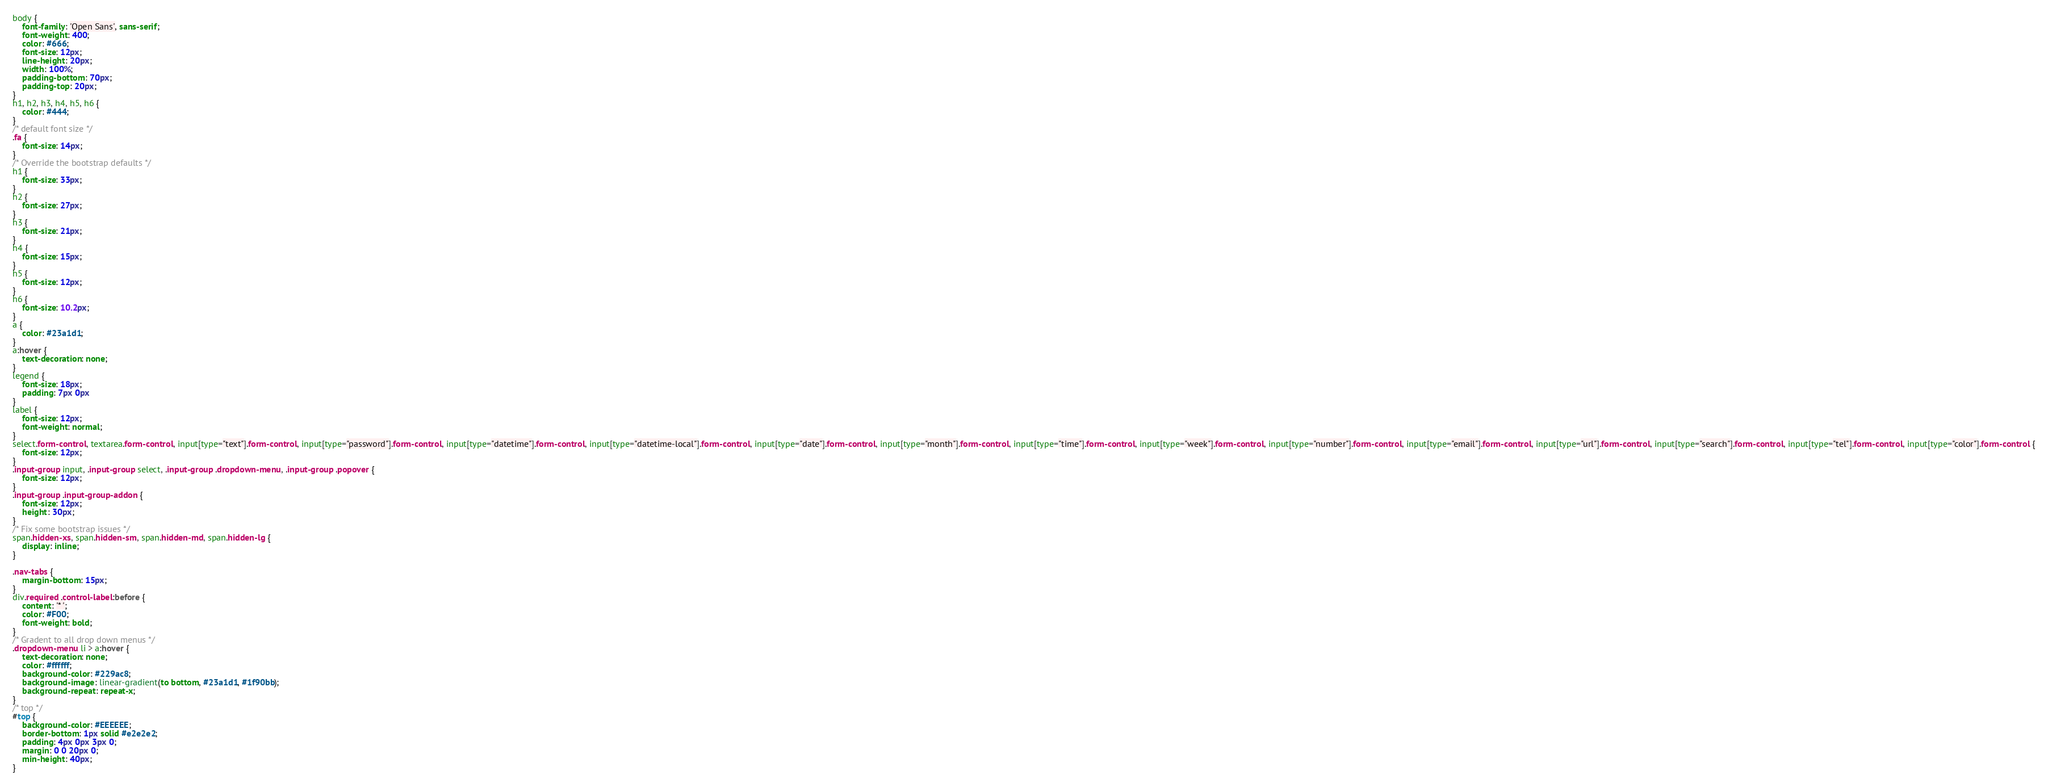<code> <loc_0><loc_0><loc_500><loc_500><_CSS_>body {
	font-family: 'Open Sans', sans-serif;
	font-weight: 400;
	color: #666;
	font-size: 12px;
	line-height: 20px;
	width: 100%;
	padding-bottom: 70px;
	padding-top: 20px;
}
h1, h2, h3, h4, h5, h6 {
	color: #444;
}
/* default font size */
.fa {
	font-size: 14px;
}
/* Override the bootstrap defaults */
h1 {
	font-size: 33px;
}
h2 {
	font-size: 27px;
}
h3 {
	font-size: 21px;
}
h4 {
	font-size: 15px;
}
h5 {
	font-size: 12px;
}
h6 {
	font-size: 10.2px;
}
a {
	color: #23a1d1;
}
a:hover {
	text-decoration: none;
}
legend {
	font-size: 18px;
	padding: 7px 0px
}
label {
	font-size: 12px;
	font-weight: normal;
}
select.form-control, textarea.form-control, input[type="text"].form-control, input[type="password"].form-control, input[type="datetime"].form-control, input[type="datetime-local"].form-control, input[type="date"].form-control, input[type="month"].form-control, input[type="time"].form-control, input[type="week"].form-control, input[type="number"].form-control, input[type="email"].form-control, input[type="url"].form-control, input[type="search"].form-control, input[type="tel"].form-control, input[type="color"].form-control {
	font-size: 12px;
}
.input-group input, .input-group select, .input-group .dropdown-menu, .input-group .popover {
	font-size: 12px;
}
.input-group .input-group-addon {
	font-size: 12px;
	height: 30px;
}
/* Fix some bootstrap issues */
span.hidden-xs, span.hidden-sm, span.hidden-md, span.hidden-lg {
	display: inline;
}

.nav-tabs {
	margin-bottom: 15px;
}
div.required .control-label:before {
	content: '* ';
	color: #F00;
	font-weight: bold;
}
/* Gradent to all drop down menus */
.dropdown-menu li > a:hover {
	text-decoration: none;
	color: #ffffff;
	background-color: #229ac8;
	background-image: linear-gradient(to bottom, #23a1d1, #1f90bb);
	background-repeat: repeat-x;
}
/* top */
#top {
	background-color: #EEEEEE;
	border-bottom: 1px solid #e2e2e2;
	padding: 4px 0px 3px 0;
	margin: 0 0 20px 0;
	min-height: 40px;
}</code> 